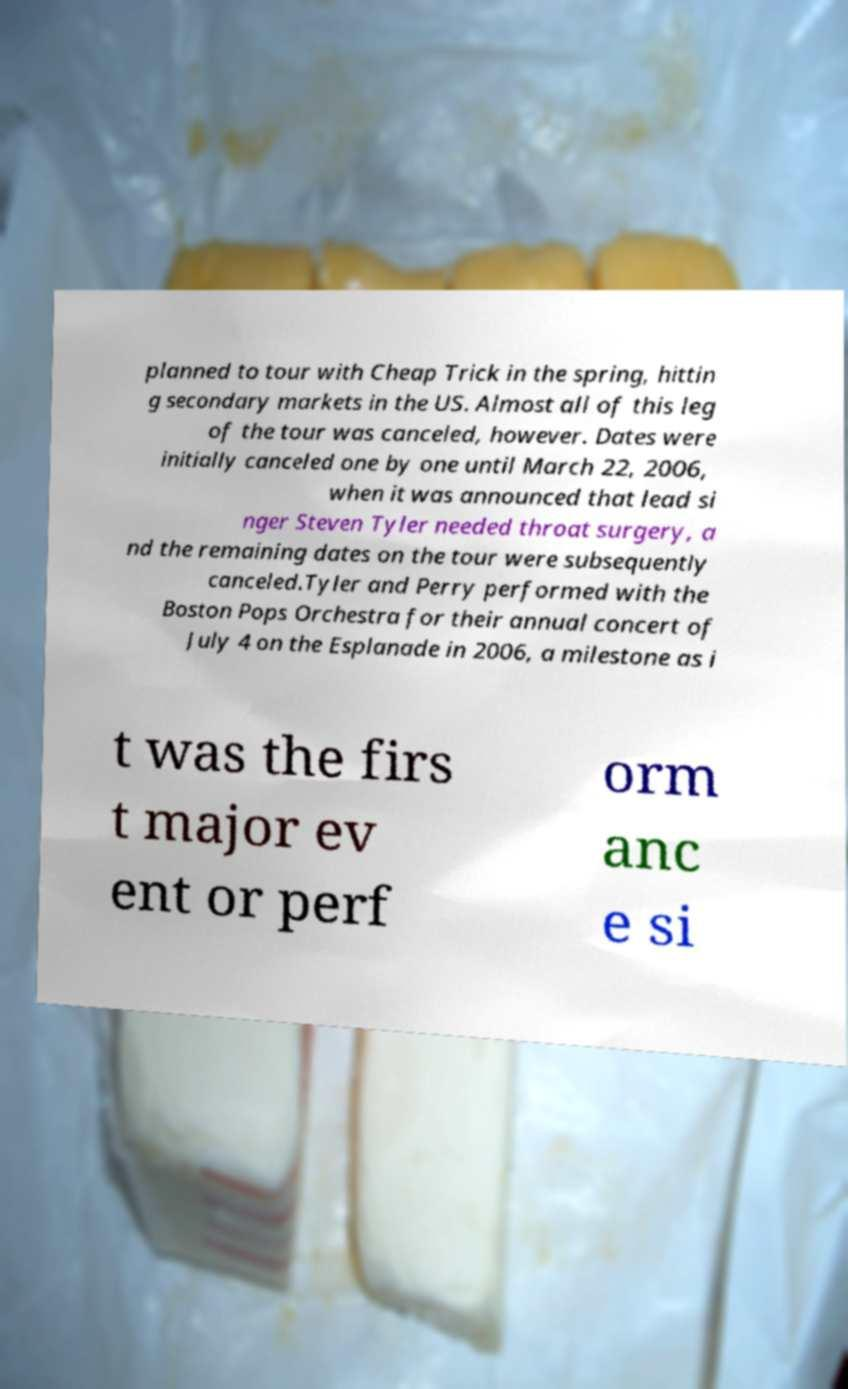What messages or text are displayed in this image? I need them in a readable, typed format. planned to tour with Cheap Trick in the spring, hittin g secondary markets in the US. Almost all of this leg of the tour was canceled, however. Dates were initially canceled one by one until March 22, 2006, when it was announced that lead si nger Steven Tyler needed throat surgery, a nd the remaining dates on the tour were subsequently canceled.Tyler and Perry performed with the Boston Pops Orchestra for their annual concert of July 4 on the Esplanade in 2006, a milestone as i t was the firs t major ev ent or perf orm anc e si 